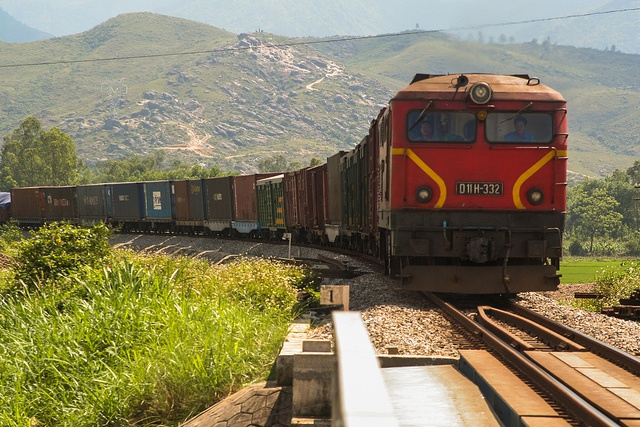Describe the objects in this image and their specific colors. I can see train in lightblue, black, maroon, and gray tones, people in lightblue, darkblue, and black tones, and people in lightblue and black tones in this image. 